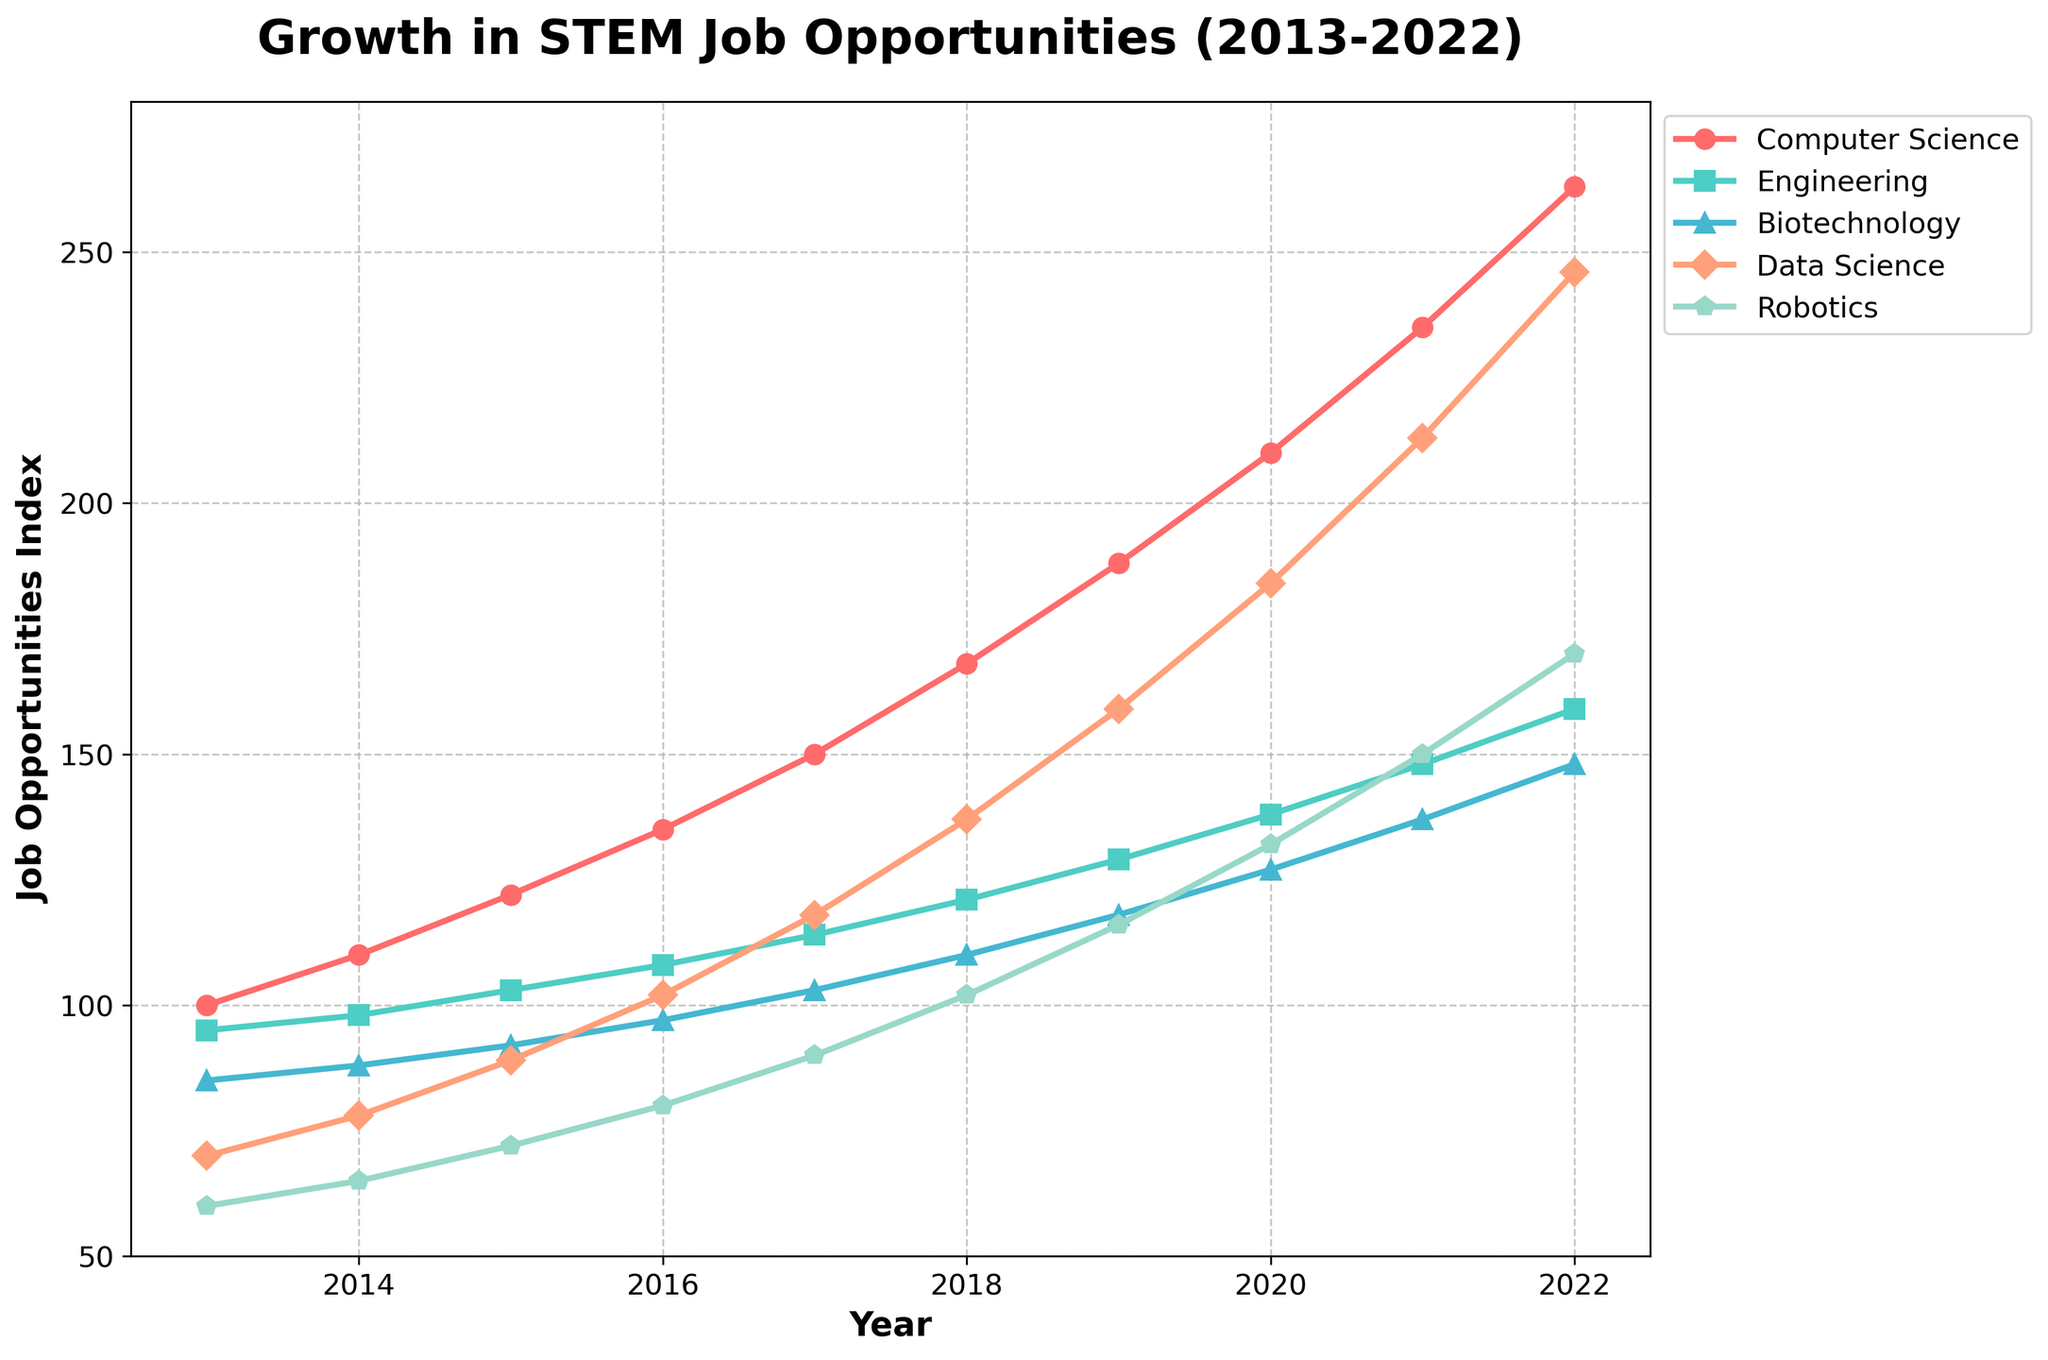What is the trend in job opportunities for Robotics over the decade? Looking at the line representing Robotics, it shows a steady increase from approximately 60 in 2013 to 170 in 2022.
Answer: Steady increase Which year did Data Science surpass 200 job opportunities? Find the point on the Data Science line that crosses the 200 mark. It occurs in 2021.
Answer: 2021 In which year did Computer Science have approximately 150 job opportunities? Find where the Computer Science line intersects near the 150 mark, which is around 2017.
Answer: 2017 How many more job opportunities were there in Computer Science than in Engineering in 2022? Compare the values for Computer Science (263) and Engineering (159) in 2022 and find the difference: 263 - 159 = 104.
Answer: 104 Which field experienced the highest growth in job opportunities from 2018 to 2022? Calculate the differences for each field between 2018 and 2022. The field with the highest difference is Computer Science (263 - 168 = 95).
Answer: Computer Science How does the job growth in Biotechnology compare to that in Engineering in 2020? Compare the points for Biotechnology (127) and Engineering (138) in 2020. Engineering is slightly higher.
Answer: Engineering is higher What is the average number of job opportunities in Data Science from 2013 to 2022? Calculate the sum of job opportunities in Data Science for each year and divide by the number of years: (70 + 78 + 89 + 102 + 118 + 137 + 159 + 184 + 213 + 246) / 10 = 1396 / 10 = 139.6.
Answer: 139.6 Which field had the slowest growth in job opportunities over the entire decade? Compare the increases for each field from 2013 to 2022. Biotechnology had the smallest increase (148 - 85 = 63).
Answer: Biotechnology In which year did Robotics have equal job opportunities to Computer Science in 2013? Find the point where the Robotics line matches the value of Computer Science in 2013 (100). It happens around 2017.
Answer: 2017 What is the ratio of job opportunities in Computer Science to Data Science in 2022? Divide the values for Computer Science (263) by Data Science (246) in 2022: 263 / 246 ≈ 1.07.
Answer: 1.07 